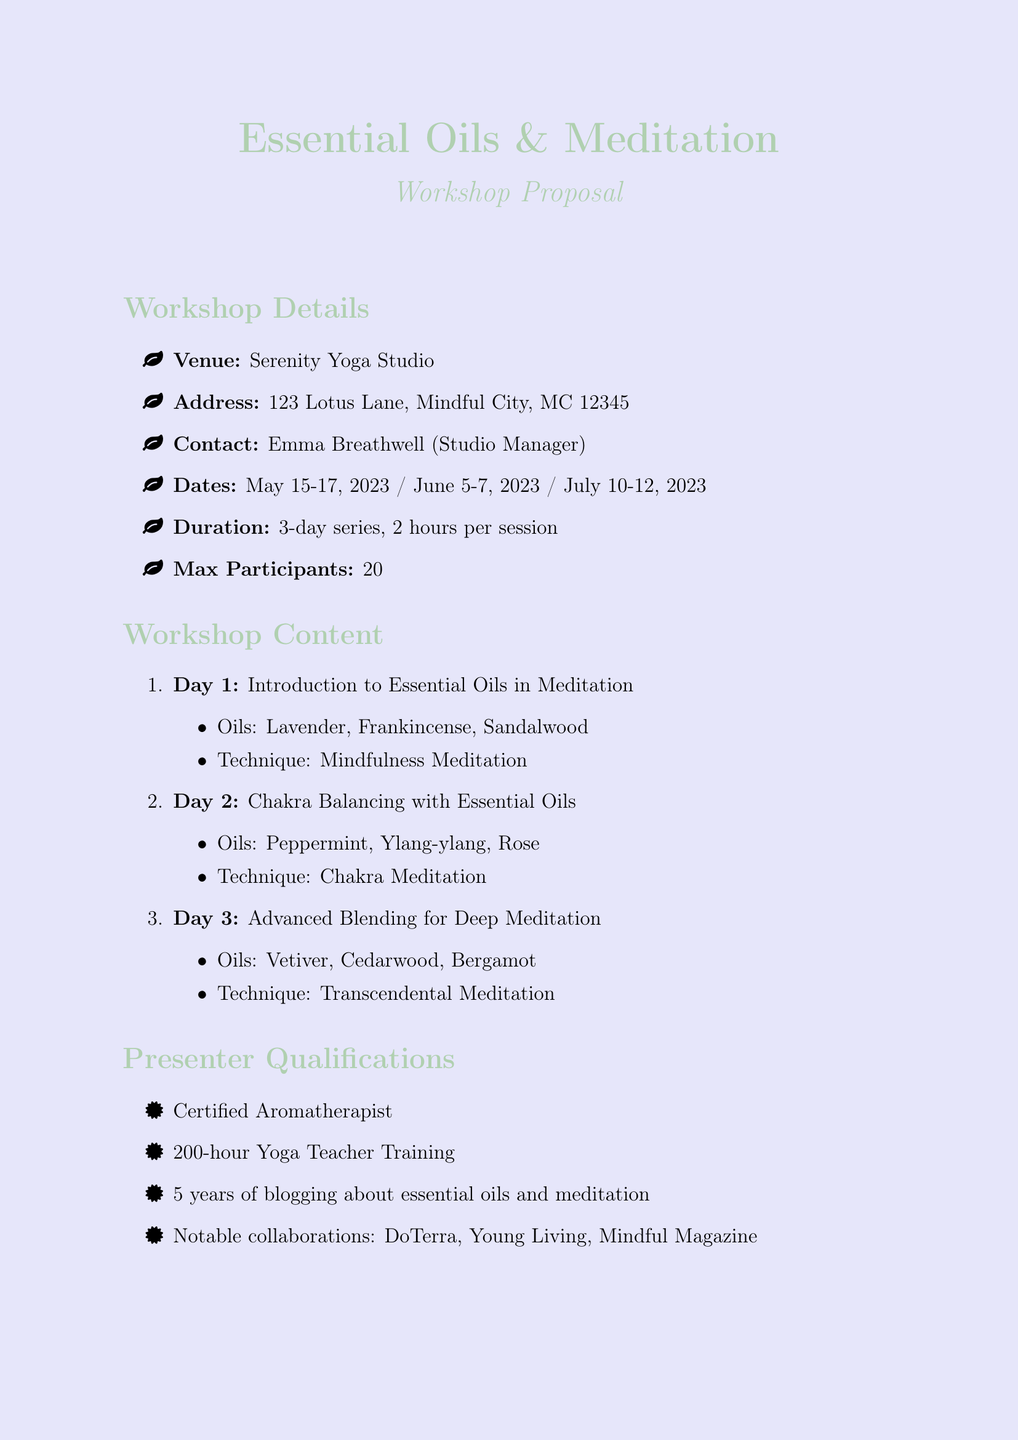What is the venue for the workshop? The venue is mentioned as Serenity Yoga Studio in the document.
Answer: Serenity Yoga Studio Who is the contact person for the workshop? The document specifies that Emma Breathwell is the Studio Manager and the contact person.
Answer: Emma Breathwell How many days does the workshop series last? The duration mentioned in the document is a 3-day series.
Answer: 3-day series What is the maximum number of participants allowed? The document states the maximum participants as 20.
Answer: 20 Which essential oil is covered on Day 2? The document lists Peppermint, Ylang-ylang, and Rose as the oils covered on Day 2.
Answer: Peppermint, Ylang-ylang, Rose What meditation technique is associated with Day 1? The document indicates that the technique for Day 1 is Mindfulness Meditation.
Answer: Mindfulness Meditation What is a benefit of attending the workshop? The document lists several benefits, including enhanced relaxation and stress reduction.
Answer: Enhanced relaxation and stress reduction What materials are needed for the workshop? The document itemizes the required materials, including high-quality essential oils and diffusers.
Answer: High-quality essential oils from reputable brands What promotional idea includes social media? The document mentions a social media campaign featuring teaser videos of oil blending as a promotional idea.
Answer: Social media campaign featuring teaser videos of oil blending What is a follow-up opportunity mentioned in the document? The document outlines several follow-up opportunities, including monthly essential oil meditation circles at the studio.
Answer: Monthly essential oil meditation circles at the studio 